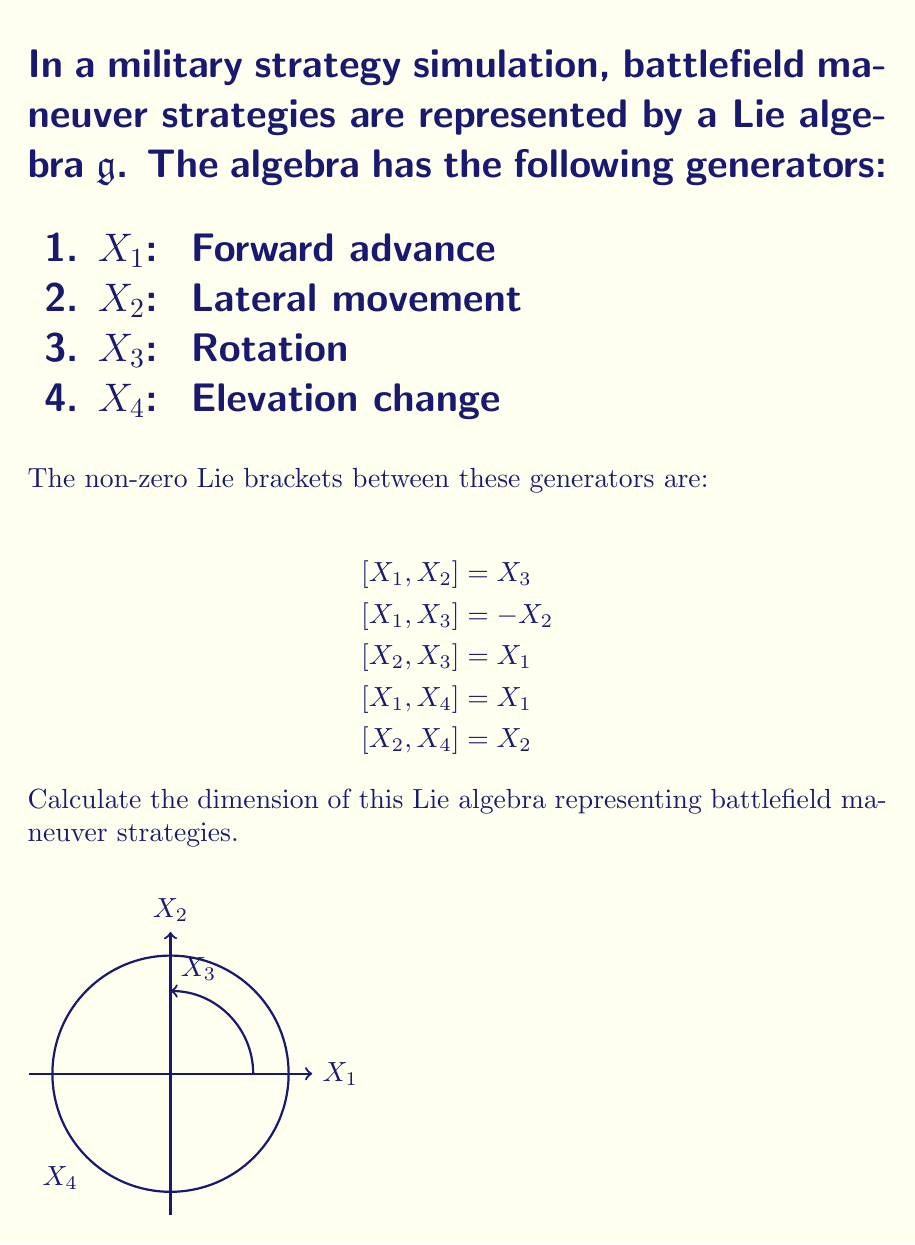Give your solution to this math problem. To determine the dimension of the Lie algebra $\mathfrak{g}$, we need to find the number of linearly independent generators. Let's approach this step-by-step:

1) We start with four generators: $X_1$, $X_2$, $X_3$, and $X_4$.

2) To check for linear independence, we need to examine the Lie brackets:

   $$[X_1, X_2] = X_3$$
   $$[X_1, X_3] = -X_2$$
   $$[X_2, X_3] = X_1$$
   $$[X_1, X_4] = X_1$$
   $$[X_2, X_4] = X_2$$

3) From these brackets, we can see that $X_1$, $X_2$, and $X_3$ form a closed subalgebra. This subalgebra is isomorphic to $\mathfrak{so}(3)$, the Lie algebra of 3D rotations.

4) $X_4$ doesn't close with the other generators to form a new element, but it does scale $X_1$ and $X_2$. This indicates that $X_4$ represents a scaling or dilation operation.

5) Importantly, there are no Lie brackets that express any of the generators as linear combinations of the others. This means that all four generators are linearly independent.

6) In Lie algebra theory, the dimension of the algebra is equal to the number of linearly independent generators.

Therefore, the dimension of the Lie algebra $\mathfrak{g}$ is 4.
Answer: 4 